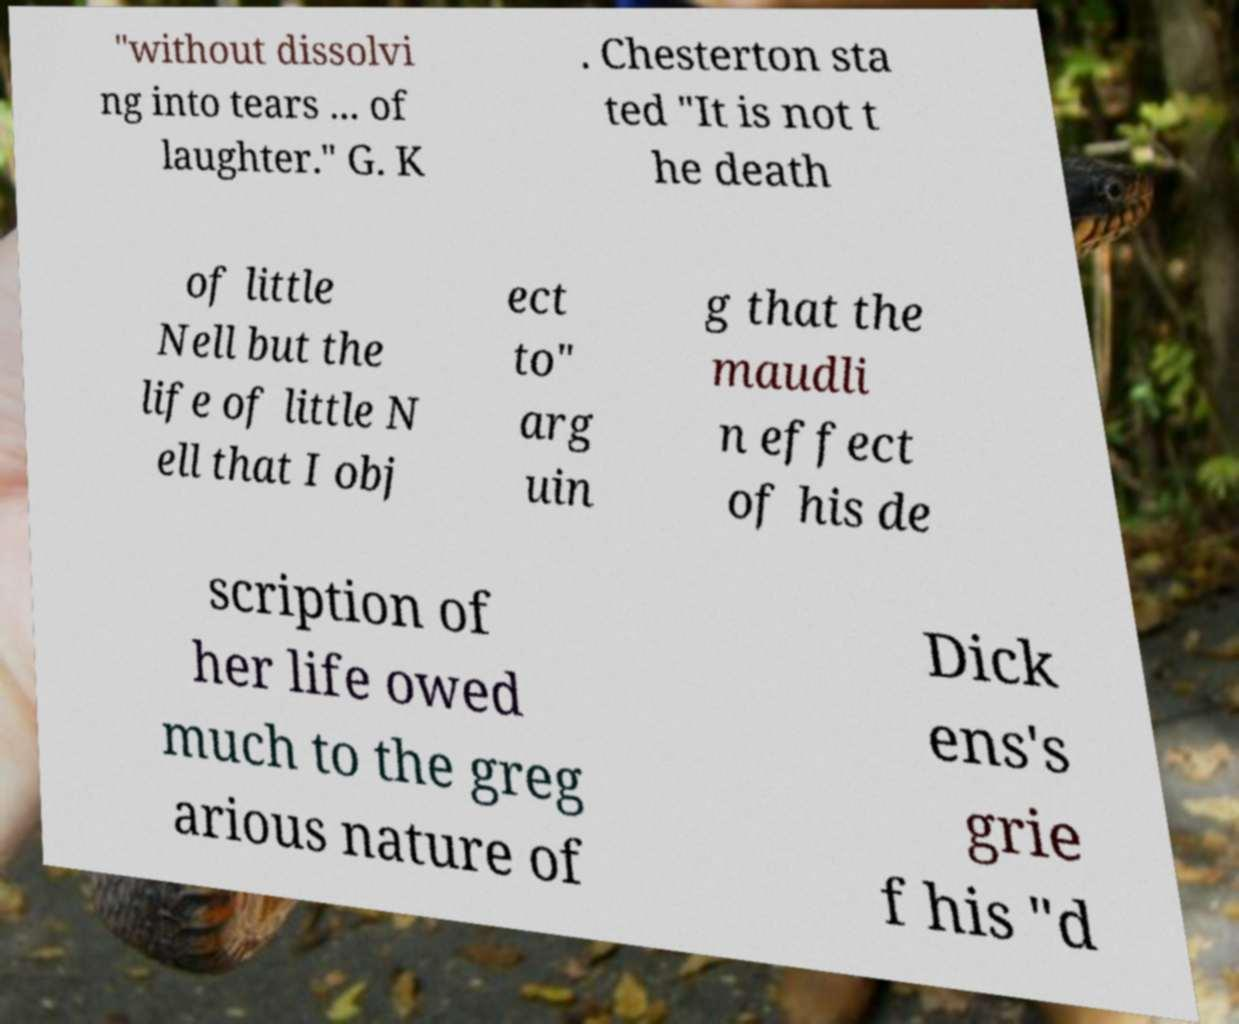Please read and relay the text visible in this image. What does it say? "without dissolvi ng into tears ... of laughter." G. K . Chesterton sta ted "It is not t he death of little Nell but the life of little N ell that I obj ect to" arg uin g that the maudli n effect of his de scription of her life owed much to the greg arious nature of Dick ens's grie f his "d 